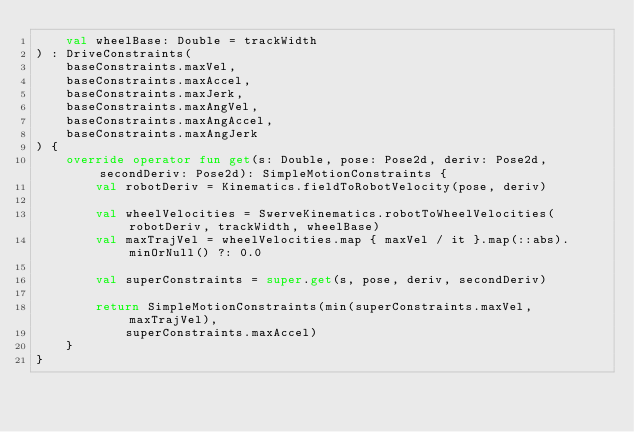<code> <loc_0><loc_0><loc_500><loc_500><_Kotlin_>    val wheelBase: Double = trackWidth
) : DriveConstraints(
    baseConstraints.maxVel,
    baseConstraints.maxAccel,
    baseConstraints.maxJerk,
    baseConstraints.maxAngVel,
    baseConstraints.maxAngAccel,
    baseConstraints.maxAngJerk
) {
    override operator fun get(s: Double, pose: Pose2d, deriv: Pose2d, secondDeriv: Pose2d): SimpleMotionConstraints {
        val robotDeriv = Kinematics.fieldToRobotVelocity(pose, deriv)

        val wheelVelocities = SwerveKinematics.robotToWheelVelocities(robotDeriv, trackWidth, wheelBase)
        val maxTrajVel = wheelVelocities.map { maxVel / it }.map(::abs).minOrNull() ?: 0.0

        val superConstraints = super.get(s, pose, deriv, secondDeriv)

        return SimpleMotionConstraints(min(superConstraints.maxVel, maxTrajVel),
            superConstraints.maxAccel)
    }
}
</code> 